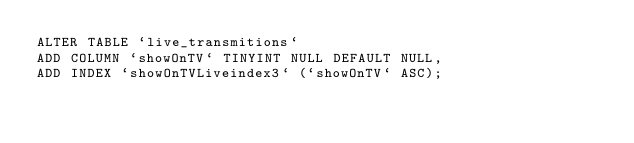<code> <loc_0><loc_0><loc_500><loc_500><_SQL_>ALTER TABLE `live_transmitions` 
ADD COLUMN `showOnTV` TINYINT NULL DEFAULT NULL,
ADD INDEX `showOnTVLiveindex3` (`showOnTV` ASC);</code> 